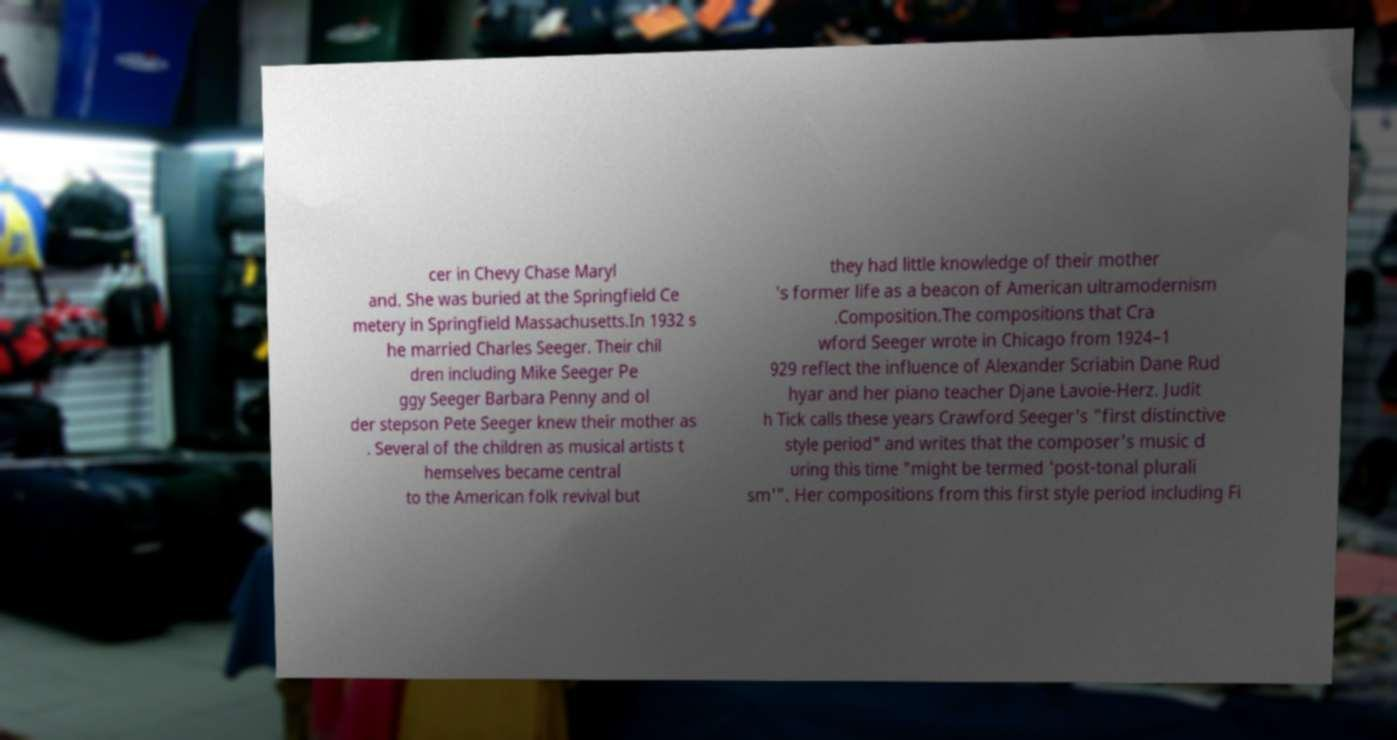Could you assist in decoding the text presented in this image and type it out clearly? cer in Chevy Chase Maryl and. She was buried at the Springfield Ce metery in Springfield Massachusetts.In 1932 s he married Charles Seeger. Their chil dren including Mike Seeger Pe ggy Seeger Barbara Penny and ol der stepson Pete Seeger knew their mother as . Several of the children as musical artists t hemselves became central to the American folk revival but they had little knowledge of their mother 's former life as a beacon of American ultramodernism .Composition.The compositions that Cra wford Seeger wrote in Chicago from 1924–1 929 reflect the influence of Alexander Scriabin Dane Rud hyar and her piano teacher Djane Lavoie-Herz. Judit h Tick calls these years Crawford Seeger's "first distinctive style period" and writes that the composer's music d uring this time "might be termed 'post-tonal plurali sm'". Her compositions from this first style period including Fi 